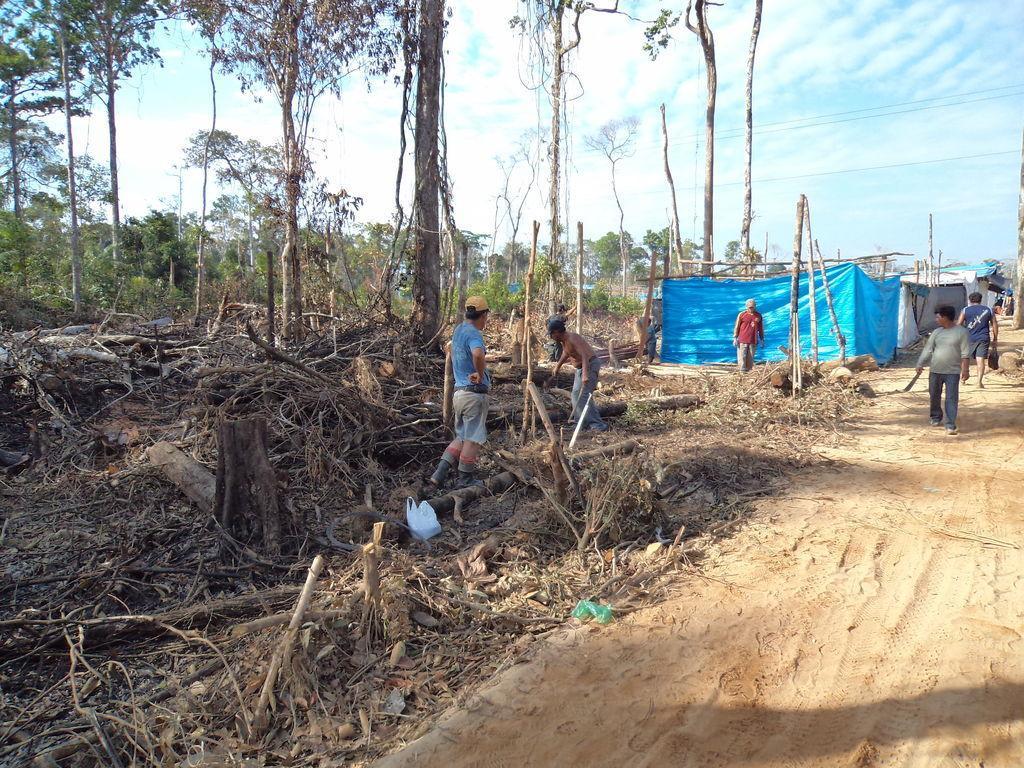Could you give a brief overview of what you see in this image? In this picture I can see group of people standing, there are tree trunks, branches, these are looking like houses, there are trees, cables, and in the background there is sky. 